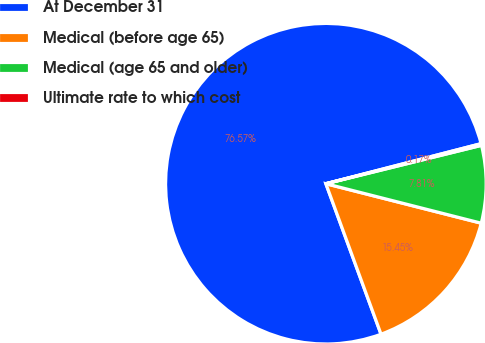Convert chart to OTSL. <chart><loc_0><loc_0><loc_500><loc_500><pie_chart><fcel>At December 31<fcel>Medical (before age 65)<fcel>Medical (age 65 and older)<fcel>Ultimate rate to which cost<nl><fcel>76.57%<fcel>15.45%<fcel>7.81%<fcel>0.17%<nl></chart> 